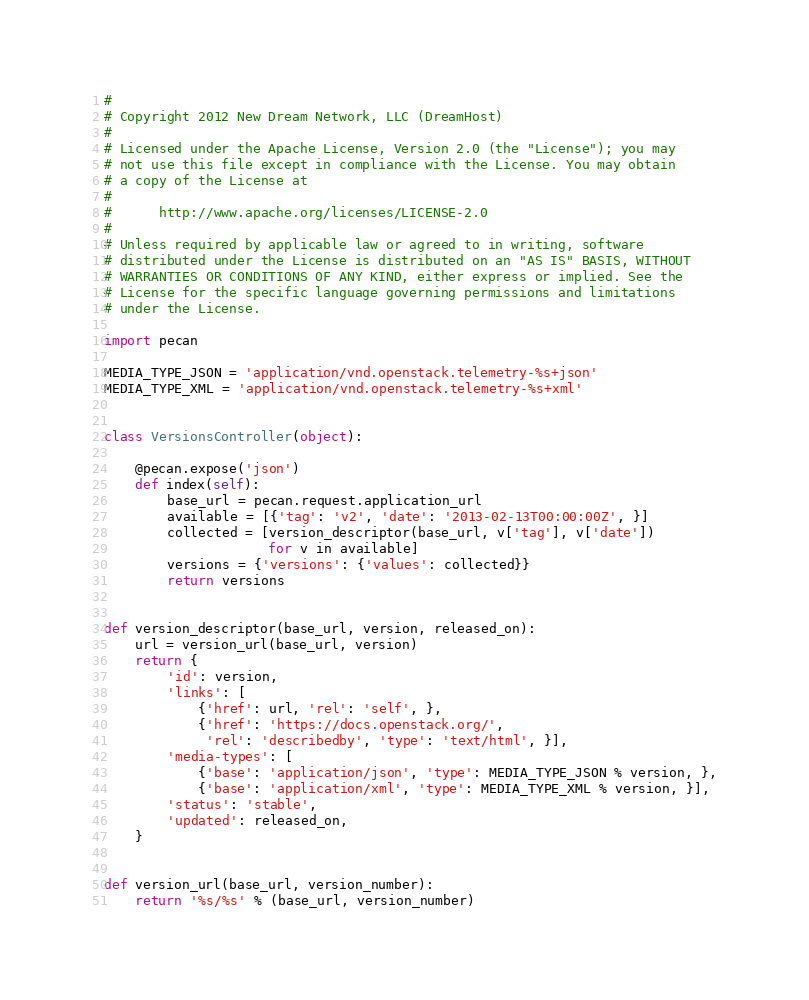<code> <loc_0><loc_0><loc_500><loc_500><_Python_>#
# Copyright 2012 New Dream Network, LLC (DreamHost)
#
# Licensed under the Apache License, Version 2.0 (the "License"); you may
# not use this file except in compliance with the License. You may obtain
# a copy of the License at
#
#      http://www.apache.org/licenses/LICENSE-2.0
#
# Unless required by applicable law or agreed to in writing, software
# distributed under the License is distributed on an "AS IS" BASIS, WITHOUT
# WARRANTIES OR CONDITIONS OF ANY KIND, either express or implied. See the
# License for the specific language governing permissions and limitations
# under the License.

import pecan

MEDIA_TYPE_JSON = 'application/vnd.openstack.telemetry-%s+json'
MEDIA_TYPE_XML = 'application/vnd.openstack.telemetry-%s+xml'


class VersionsController(object):

    @pecan.expose('json')
    def index(self):
        base_url = pecan.request.application_url
        available = [{'tag': 'v2', 'date': '2013-02-13T00:00:00Z', }]
        collected = [version_descriptor(base_url, v['tag'], v['date'])
                     for v in available]
        versions = {'versions': {'values': collected}}
        return versions


def version_descriptor(base_url, version, released_on):
    url = version_url(base_url, version)
    return {
        'id': version,
        'links': [
            {'href': url, 'rel': 'self', },
            {'href': 'https://docs.openstack.org/',
             'rel': 'describedby', 'type': 'text/html', }],
        'media-types': [
            {'base': 'application/json', 'type': MEDIA_TYPE_JSON % version, },
            {'base': 'application/xml', 'type': MEDIA_TYPE_XML % version, }],
        'status': 'stable',
        'updated': released_on,
    }


def version_url(base_url, version_number):
    return '%s/%s' % (base_url, version_number)
</code> 